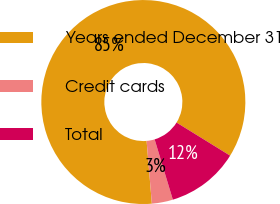<chart> <loc_0><loc_0><loc_500><loc_500><pie_chart><fcel>Years ended December 31<fcel>Credit cards<fcel>Total<nl><fcel>85.14%<fcel>3.34%<fcel>11.52%<nl></chart> 